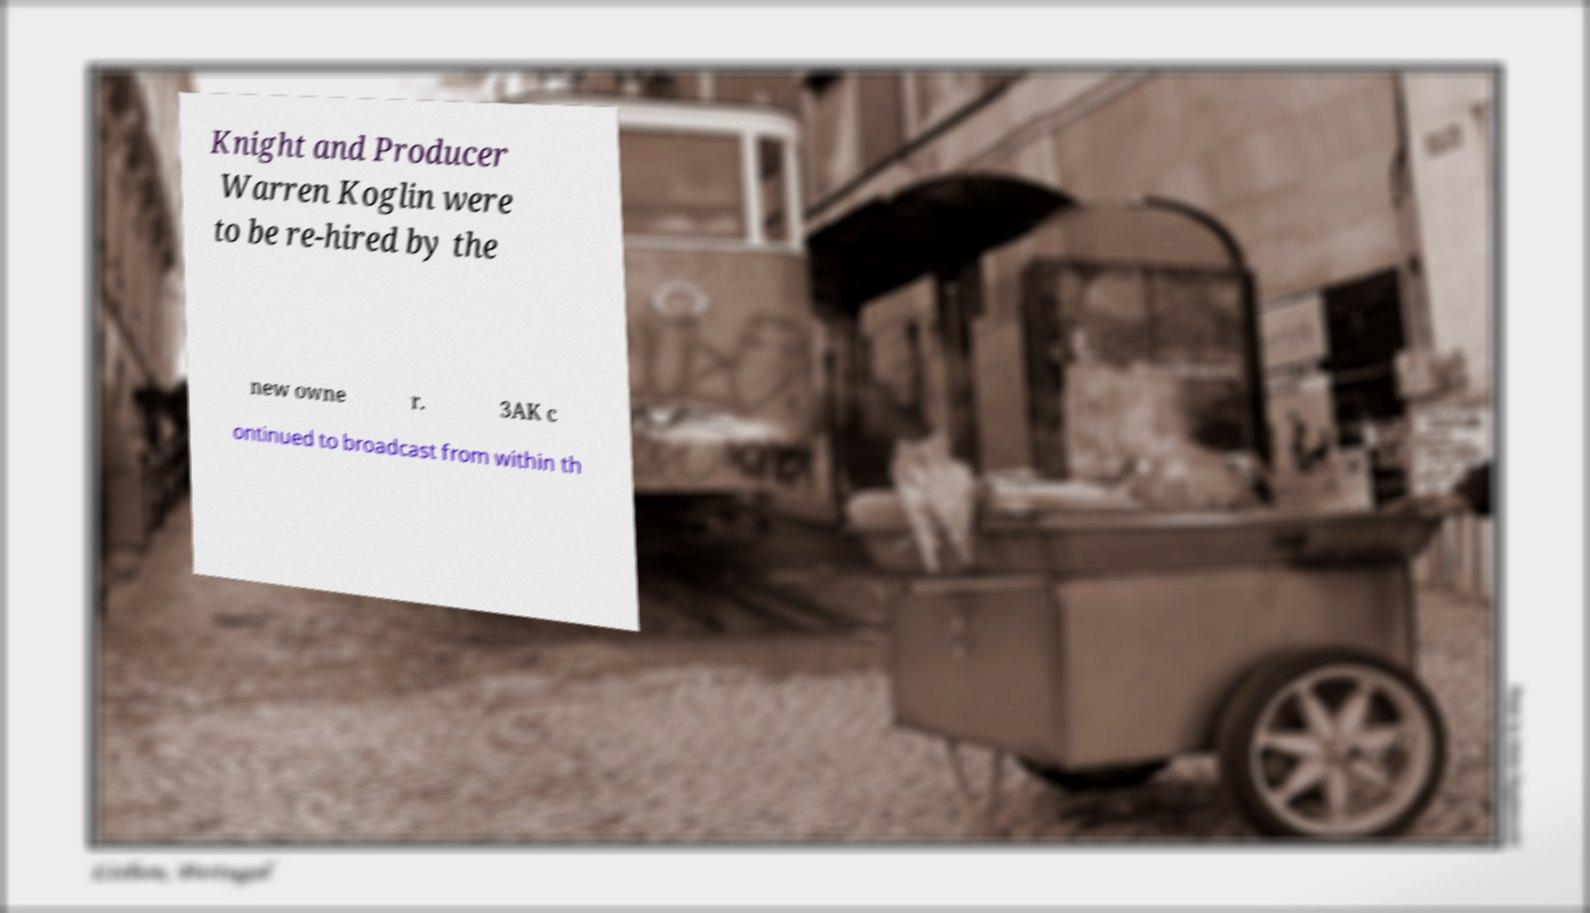Could you assist in decoding the text presented in this image and type it out clearly? Knight and Producer Warren Koglin were to be re-hired by the new owne r. 3AK c ontinued to broadcast from within th 